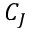<formula> <loc_0><loc_0><loc_500><loc_500>C _ { J }</formula> 